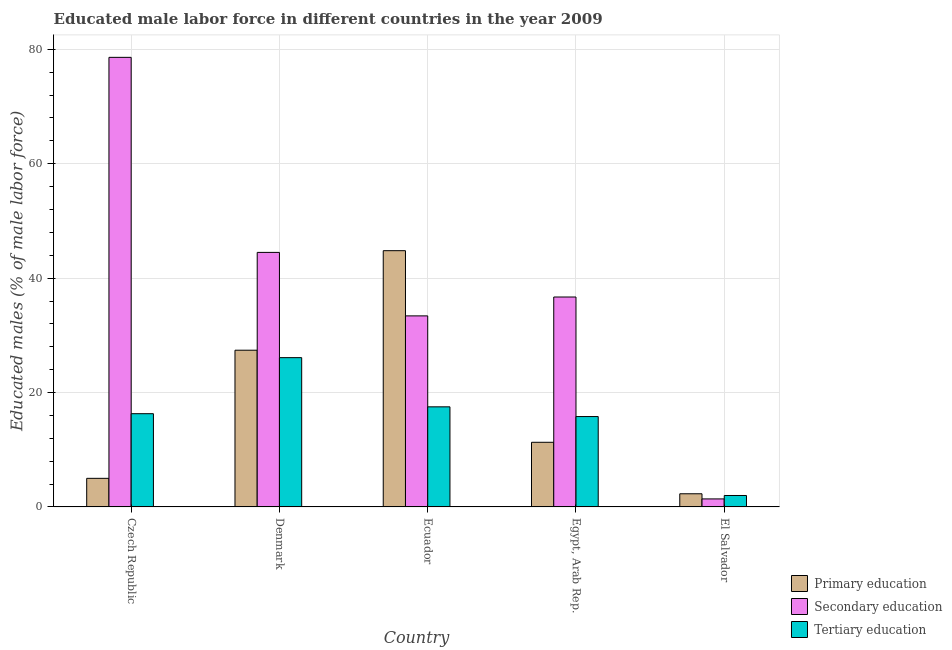Are the number of bars per tick equal to the number of legend labels?
Keep it short and to the point. Yes. Are the number of bars on each tick of the X-axis equal?
Give a very brief answer. Yes. How many bars are there on the 2nd tick from the left?
Your response must be concise. 3. What is the label of the 4th group of bars from the left?
Your answer should be compact. Egypt, Arab Rep. Across all countries, what is the maximum percentage of male labor force who received tertiary education?
Ensure brevity in your answer.  26.1. Across all countries, what is the minimum percentage of male labor force who received secondary education?
Offer a very short reply. 1.4. In which country was the percentage of male labor force who received secondary education maximum?
Your answer should be compact. Czech Republic. In which country was the percentage of male labor force who received primary education minimum?
Keep it short and to the point. El Salvador. What is the total percentage of male labor force who received tertiary education in the graph?
Your answer should be very brief. 77.7. What is the difference between the percentage of male labor force who received primary education in Denmark and that in El Salvador?
Give a very brief answer. 25.1. What is the difference between the percentage of male labor force who received primary education in Ecuador and the percentage of male labor force who received tertiary education in El Salvador?
Provide a succinct answer. 42.8. What is the average percentage of male labor force who received primary education per country?
Provide a succinct answer. 18.16. What is the difference between the percentage of male labor force who received tertiary education and percentage of male labor force who received secondary education in Egypt, Arab Rep.?
Offer a very short reply. -20.9. In how many countries, is the percentage of male labor force who received tertiary education greater than 8 %?
Make the answer very short. 4. What is the ratio of the percentage of male labor force who received secondary education in Denmark to that in Ecuador?
Your response must be concise. 1.33. Is the percentage of male labor force who received secondary education in Denmark less than that in El Salvador?
Make the answer very short. No. What is the difference between the highest and the second highest percentage of male labor force who received tertiary education?
Give a very brief answer. 8.6. What is the difference between the highest and the lowest percentage of male labor force who received primary education?
Offer a very short reply. 42.5. In how many countries, is the percentage of male labor force who received secondary education greater than the average percentage of male labor force who received secondary education taken over all countries?
Give a very brief answer. 2. Is the sum of the percentage of male labor force who received tertiary education in Denmark and Ecuador greater than the maximum percentage of male labor force who received primary education across all countries?
Provide a short and direct response. No. What does the 3rd bar from the left in El Salvador represents?
Provide a succinct answer. Tertiary education. What does the 1st bar from the right in El Salvador represents?
Your answer should be compact. Tertiary education. How many bars are there?
Make the answer very short. 15. What is the difference between two consecutive major ticks on the Y-axis?
Keep it short and to the point. 20. Where does the legend appear in the graph?
Offer a very short reply. Bottom right. How are the legend labels stacked?
Provide a succinct answer. Vertical. What is the title of the graph?
Keep it short and to the point. Educated male labor force in different countries in the year 2009. What is the label or title of the Y-axis?
Your response must be concise. Educated males (% of male labor force). What is the Educated males (% of male labor force) in Primary education in Czech Republic?
Ensure brevity in your answer.  5. What is the Educated males (% of male labor force) in Secondary education in Czech Republic?
Keep it short and to the point. 78.6. What is the Educated males (% of male labor force) of Tertiary education in Czech Republic?
Make the answer very short. 16.3. What is the Educated males (% of male labor force) in Primary education in Denmark?
Provide a succinct answer. 27.4. What is the Educated males (% of male labor force) in Secondary education in Denmark?
Provide a short and direct response. 44.5. What is the Educated males (% of male labor force) in Tertiary education in Denmark?
Give a very brief answer. 26.1. What is the Educated males (% of male labor force) in Primary education in Ecuador?
Your answer should be very brief. 44.8. What is the Educated males (% of male labor force) in Secondary education in Ecuador?
Give a very brief answer. 33.4. What is the Educated males (% of male labor force) of Primary education in Egypt, Arab Rep.?
Ensure brevity in your answer.  11.3. What is the Educated males (% of male labor force) of Secondary education in Egypt, Arab Rep.?
Offer a terse response. 36.7. What is the Educated males (% of male labor force) in Tertiary education in Egypt, Arab Rep.?
Provide a short and direct response. 15.8. What is the Educated males (% of male labor force) of Primary education in El Salvador?
Your answer should be compact. 2.3. What is the Educated males (% of male labor force) of Secondary education in El Salvador?
Provide a succinct answer. 1.4. Across all countries, what is the maximum Educated males (% of male labor force) in Primary education?
Make the answer very short. 44.8. Across all countries, what is the maximum Educated males (% of male labor force) in Secondary education?
Offer a terse response. 78.6. Across all countries, what is the maximum Educated males (% of male labor force) of Tertiary education?
Your answer should be very brief. 26.1. Across all countries, what is the minimum Educated males (% of male labor force) in Primary education?
Make the answer very short. 2.3. Across all countries, what is the minimum Educated males (% of male labor force) of Secondary education?
Offer a terse response. 1.4. What is the total Educated males (% of male labor force) in Primary education in the graph?
Your response must be concise. 90.8. What is the total Educated males (% of male labor force) in Secondary education in the graph?
Your answer should be compact. 194.6. What is the total Educated males (% of male labor force) of Tertiary education in the graph?
Ensure brevity in your answer.  77.7. What is the difference between the Educated males (% of male labor force) of Primary education in Czech Republic and that in Denmark?
Your answer should be very brief. -22.4. What is the difference between the Educated males (% of male labor force) of Secondary education in Czech Republic and that in Denmark?
Your answer should be very brief. 34.1. What is the difference between the Educated males (% of male labor force) of Primary education in Czech Republic and that in Ecuador?
Your response must be concise. -39.8. What is the difference between the Educated males (% of male labor force) in Secondary education in Czech Republic and that in Ecuador?
Give a very brief answer. 45.2. What is the difference between the Educated males (% of male labor force) of Secondary education in Czech Republic and that in Egypt, Arab Rep.?
Make the answer very short. 41.9. What is the difference between the Educated males (% of male labor force) of Tertiary education in Czech Republic and that in Egypt, Arab Rep.?
Provide a short and direct response. 0.5. What is the difference between the Educated males (% of male labor force) in Secondary education in Czech Republic and that in El Salvador?
Provide a succinct answer. 77.2. What is the difference between the Educated males (% of male labor force) of Tertiary education in Czech Republic and that in El Salvador?
Your answer should be very brief. 14.3. What is the difference between the Educated males (% of male labor force) in Primary education in Denmark and that in Ecuador?
Give a very brief answer. -17.4. What is the difference between the Educated males (% of male labor force) in Secondary education in Denmark and that in Ecuador?
Make the answer very short. 11.1. What is the difference between the Educated males (% of male labor force) of Tertiary education in Denmark and that in Ecuador?
Make the answer very short. 8.6. What is the difference between the Educated males (% of male labor force) of Secondary education in Denmark and that in Egypt, Arab Rep.?
Provide a succinct answer. 7.8. What is the difference between the Educated males (% of male labor force) in Tertiary education in Denmark and that in Egypt, Arab Rep.?
Offer a terse response. 10.3. What is the difference between the Educated males (% of male labor force) of Primary education in Denmark and that in El Salvador?
Your response must be concise. 25.1. What is the difference between the Educated males (% of male labor force) in Secondary education in Denmark and that in El Salvador?
Ensure brevity in your answer.  43.1. What is the difference between the Educated males (% of male labor force) in Tertiary education in Denmark and that in El Salvador?
Your answer should be compact. 24.1. What is the difference between the Educated males (% of male labor force) of Primary education in Ecuador and that in Egypt, Arab Rep.?
Offer a terse response. 33.5. What is the difference between the Educated males (% of male labor force) in Tertiary education in Ecuador and that in Egypt, Arab Rep.?
Make the answer very short. 1.7. What is the difference between the Educated males (% of male labor force) of Primary education in Ecuador and that in El Salvador?
Offer a very short reply. 42.5. What is the difference between the Educated males (% of male labor force) in Secondary education in Ecuador and that in El Salvador?
Keep it short and to the point. 32. What is the difference between the Educated males (% of male labor force) in Tertiary education in Ecuador and that in El Salvador?
Your answer should be very brief. 15.5. What is the difference between the Educated males (% of male labor force) in Primary education in Egypt, Arab Rep. and that in El Salvador?
Provide a short and direct response. 9. What is the difference between the Educated males (% of male labor force) in Secondary education in Egypt, Arab Rep. and that in El Salvador?
Your answer should be compact. 35.3. What is the difference between the Educated males (% of male labor force) of Tertiary education in Egypt, Arab Rep. and that in El Salvador?
Your answer should be very brief. 13.8. What is the difference between the Educated males (% of male labor force) in Primary education in Czech Republic and the Educated males (% of male labor force) in Secondary education in Denmark?
Keep it short and to the point. -39.5. What is the difference between the Educated males (% of male labor force) of Primary education in Czech Republic and the Educated males (% of male labor force) of Tertiary education in Denmark?
Give a very brief answer. -21.1. What is the difference between the Educated males (% of male labor force) in Secondary education in Czech Republic and the Educated males (% of male labor force) in Tertiary education in Denmark?
Your response must be concise. 52.5. What is the difference between the Educated males (% of male labor force) of Primary education in Czech Republic and the Educated males (% of male labor force) of Secondary education in Ecuador?
Keep it short and to the point. -28.4. What is the difference between the Educated males (% of male labor force) of Primary education in Czech Republic and the Educated males (% of male labor force) of Tertiary education in Ecuador?
Your answer should be very brief. -12.5. What is the difference between the Educated males (% of male labor force) in Secondary education in Czech Republic and the Educated males (% of male labor force) in Tertiary education in Ecuador?
Provide a succinct answer. 61.1. What is the difference between the Educated males (% of male labor force) of Primary education in Czech Republic and the Educated males (% of male labor force) of Secondary education in Egypt, Arab Rep.?
Your answer should be compact. -31.7. What is the difference between the Educated males (% of male labor force) of Secondary education in Czech Republic and the Educated males (% of male labor force) of Tertiary education in Egypt, Arab Rep.?
Keep it short and to the point. 62.8. What is the difference between the Educated males (% of male labor force) in Primary education in Czech Republic and the Educated males (% of male labor force) in Tertiary education in El Salvador?
Give a very brief answer. 3. What is the difference between the Educated males (% of male labor force) of Secondary education in Czech Republic and the Educated males (% of male labor force) of Tertiary education in El Salvador?
Offer a terse response. 76.6. What is the difference between the Educated males (% of male labor force) in Primary education in Denmark and the Educated males (% of male labor force) in Tertiary education in Ecuador?
Provide a succinct answer. 9.9. What is the difference between the Educated males (% of male labor force) in Secondary education in Denmark and the Educated males (% of male labor force) in Tertiary education in Egypt, Arab Rep.?
Provide a short and direct response. 28.7. What is the difference between the Educated males (% of male labor force) in Primary education in Denmark and the Educated males (% of male labor force) in Tertiary education in El Salvador?
Give a very brief answer. 25.4. What is the difference between the Educated males (% of male labor force) of Secondary education in Denmark and the Educated males (% of male labor force) of Tertiary education in El Salvador?
Make the answer very short. 42.5. What is the difference between the Educated males (% of male labor force) in Secondary education in Ecuador and the Educated males (% of male labor force) in Tertiary education in Egypt, Arab Rep.?
Your answer should be compact. 17.6. What is the difference between the Educated males (% of male labor force) of Primary education in Ecuador and the Educated males (% of male labor force) of Secondary education in El Salvador?
Offer a very short reply. 43.4. What is the difference between the Educated males (% of male labor force) in Primary education in Ecuador and the Educated males (% of male labor force) in Tertiary education in El Salvador?
Make the answer very short. 42.8. What is the difference between the Educated males (% of male labor force) of Secondary education in Ecuador and the Educated males (% of male labor force) of Tertiary education in El Salvador?
Keep it short and to the point. 31.4. What is the difference between the Educated males (% of male labor force) of Primary education in Egypt, Arab Rep. and the Educated males (% of male labor force) of Tertiary education in El Salvador?
Your response must be concise. 9.3. What is the difference between the Educated males (% of male labor force) of Secondary education in Egypt, Arab Rep. and the Educated males (% of male labor force) of Tertiary education in El Salvador?
Provide a succinct answer. 34.7. What is the average Educated males (% of male labor force) of Primary education per country?
Give a very brief answer. 18.16. What is the average Educated males (% of male labor force) in Secondary education per country?
Your response must be concise. 38.92. What is the average Educated males (% of male labor force) of Tertiary education per country?
Make the answer very short. 15.54. What is the difference between the Educated males (% of male labor force) in Primary education and Educated males (% of male labor force) in Secondary education in Czech Republic?
Your response must be concise. -73.6. What is the difference between the Educated males (% of male labor force) in Secondary education and Educated males (% of male labor force) in Tertiary education in Czech Republic?
Your answer should be compact. 62.3. What is the difference between the Educated males (% of male labor force) of Primary education and Educated males (% of male labor force) of Secondary education in Denmark?
Provide a succinct answer. -17.1. What is the difference between the Educated males (% of male labor force) of Primary education and Educated males (% of male labor force) of Tertiary education in Denmark?
Your answer should be compact. 1.3. What is the difference between the Educated males (% of male labor force) of Primary education and Educated males (% of male labor force) of Secondary education in Ecuador?
Your answer should be compact. 11.4. What is the difference between the Educated males (% of male labor force) in Primary education and Educated males (% of male labor force) in Tertiary education in Ecuador?
Offer a very short reply. 27.3. What is the difference between the Educated males (% of male labor force) in Secondary education and Educated males (% of male labor force) in Tertiary education in Ecuador?
Provide a succinct answer. 15.9. What is the difference between the Educated males (% of male labor force) in Primary education and Educated males (% of male labor force) in Secondary education in Egypt, Arab Rep.?
Provide a succinct answer. -25.4. What is the difference between the Educated males (% of male labor force) in Secondary education and Educated males (% of male labor force) in Tertiary education in Egypt, Arab Rep.?
Keep it short and to the point. 20.9. What is the difference between the Educated males (% of male labor force) in Primary education and Educated males (% of male labor force) in Secondary education in El Salvador?
Provide a succinct answer. 0.9. What is the difference between the Educated males (% of male labor force) in Secondary education and Educated males (% of male labor force) in Tertiary education in El Salvador?
Your answer should be very brief. -0.6. What is the ratio of the Educated males (% of male labor force) of Primary education in Czech Republic to that in Denmark?
Keep it short and to the point. 0.18. What is the ratio of the Educated males (% of male labor force) in Secondary education in Czech Republic to that in Denmark?
Give a very brief answer. 1.77. What is the ratio of the Educated males (% of male labor force) of Tertiary education in Czech Republic to that in Denmark?
Your response must be concise. 0.62. What is the ratio of the Educated males (% of male labor force) in Primary education in Czech Republic to that in Ecuador?
Offer a very short reply. 0.11. What is the ratio of the Educated males (% of male labor force) in Secondary education in Czech Republic to that in Ecuador?
Offer a very short reply. 2.35. What is the ratio of the Educated males (% of male labor force) in Tertiary education in Czech Republic to that in Ecuador?
Provide a succinct answer. 0.93. What is the ratio of the Educated males (% of male labor force) of Primary education in Czech Republic to that in Egypt, Arab Rep.?
Give a very brief answer. 0.44. What is the ratio of the Educated males (% of male labor force) in Secondary education in Czech Republic to that in Egypt, Arab Rep.?
Offer a terse response. 2.14. What is the ratio of the Educated males (% of male labor force) of Tertiary education in Czech Republic to that in Egypt, Arab Rep.?
Your response must be concise. 1.03. What is the ratio of the Educated males (% of male labor force) in Primary education in Czech Republic to that in El Salvador?
Offer a very short reply. 2.17. What is the ratio of the Educated males (% of male labor force) in Secondary education in Czech Republic to that in El Salvador?
Offer a very short reply. 56.14. What is the ratio of the Educated males (% of male labor force) in Tertiary education in Czech Republic to that in El Salvador?
Provide a short and direct response. 8.15. What is the ratio of the Educated males (% of male labor force) in Primary education in Denmark to that in Ecuador?
Your response must be concise. 0.61. What is the ratio of the Educated males (% of male labor force) of Secondary education in Denmark to that in Ecuador?
Provide a short and direct response. 1.33. What is the ratio of the Educated males (% of male labor force) of Tertiary education in Denmark to that in Ecuador?
Offer a terse response. 1.49. What is the ratio of the Educated males (% of male labor force) of Primary education in Denmark to that in Egypt, Arab Rep.?
Give a very brief answer. 2.42. What is the ratio of the Educated males (% of male labor force) in Secondary education in Denmark to that in Egypt, Arab Rep.?
Your response must be concise. 1.21. What is the ratio of the Educated males (% of male labor force) of Tertiary education in Denmark to that in Egypt, Arab Rep.?
Your answer should be very brief. 1.65. What is the ratio of the Educated males (% of male labor force) of Primary education in Denmark to that in El Salvador?
Offer a very short reply. 11.91. What is the ratio of the Educated males (% of male labor force) of Secondary education in Denmark to that in El Salvador?
Your answer should be very brief. 31.79. What is the ratio of the Educated males (% of male labor force) of Tertiary education in Denmark to that in El Salvador?
Your answer should be compact. 13.05. What is the ratio of the Educated males (% of male labor force) in Primary education in Ecuador to that in Egypt, Arab Rep.?
Your answer should be compact. 3.96. What is the ratio of the Educated males (% of male labor force) of Secondary education in Ecuador to that in Egypt, Arab Rep.?
Your response must be concise. 0.91. What is the ratio of the Educated males (% of male labor force) in Tertiary education in Ecuador to that in Egypt, Arab Rep.?
Your answer should be very brief. 1.11. What is the ratio of the Educated males (% of male labor force) of Primary education in Ecuador to that in El Salvador?
Provide a succinct answer. 19.48. What is the ratio of the Educated males (% of male labor force) of Secondary education in Ecuador to that in El Salvador?
Ensure brevity in your answer.  23.86. What is the ratio of the Educated males (% of male labor force) of Tertiary education in Ecuador to that in El Salvador?
Provide a short and direct response. 8.75. What is the ratio of the Educated males (% of male labor force) in Primary education in Egypt, Arab Rep. to that in El Salvador?
Offer a terse response. 4.91. What is the ratio of the Educated males (% of male labor force) in Secondary education in Egypt, Arab Rep. to that in El Salvador?
Your response must be concise. 26.21. What is the ratio of the Educated males (% of male labor force) in Tertiary education in Egypt, Arab Rep. to that in El Salvador?
Keep it short and to the point. 7.9. What is the difference between the highest and the second highest Educated males (% of male labor force) of Secondary education?
Keep it short and to the point. 34.1. What is the difference between the highest and the second highest Educated males (% of male labor force) in Tertiary education?
Keep it short and to the point. 8.6. What is the difference between the highest and the lowest Educated males (% of male labor force) in Primary education?
Your answer should be compact. 42.5. What is the difference between the highest and the lowest Educated males (% of male labor force) of Secondary education?
Keep it short and to the point. 77.2. What is the difference between the highest and the lowest Educated males (% of male labor force) in Tertiary education?
Ensure brevity in your answer.  24.1. 